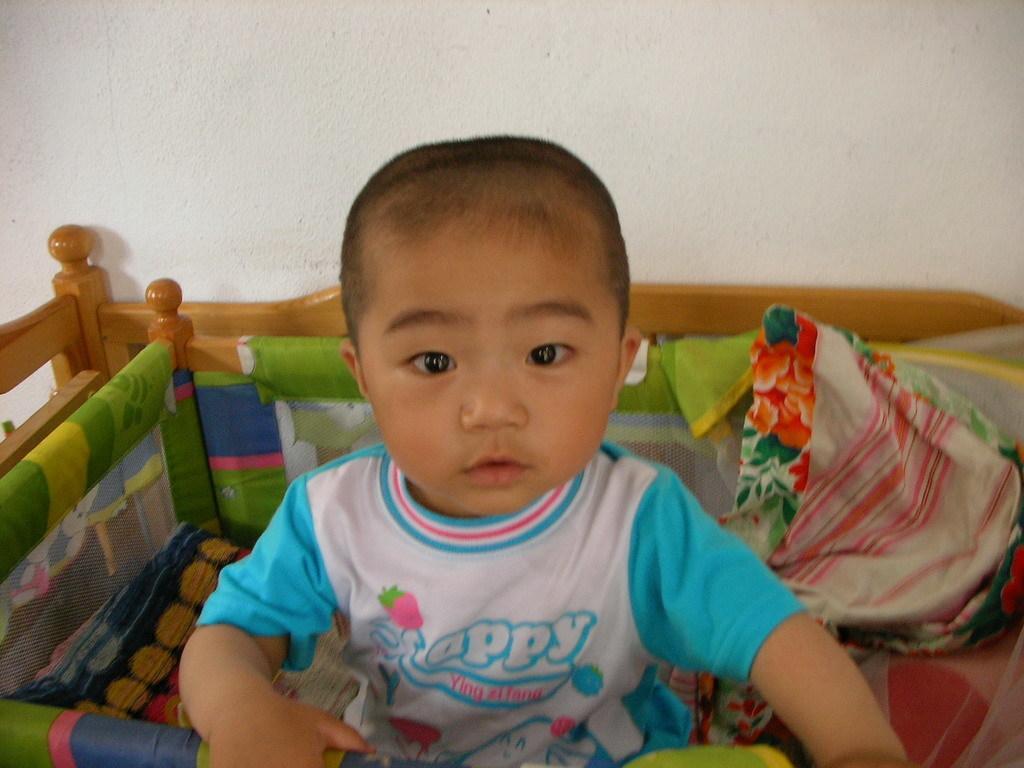In one or two sentences, can you explain what this image depicts? In this picture we can see a child, clothes, some objects and in the background we can see the wall. 